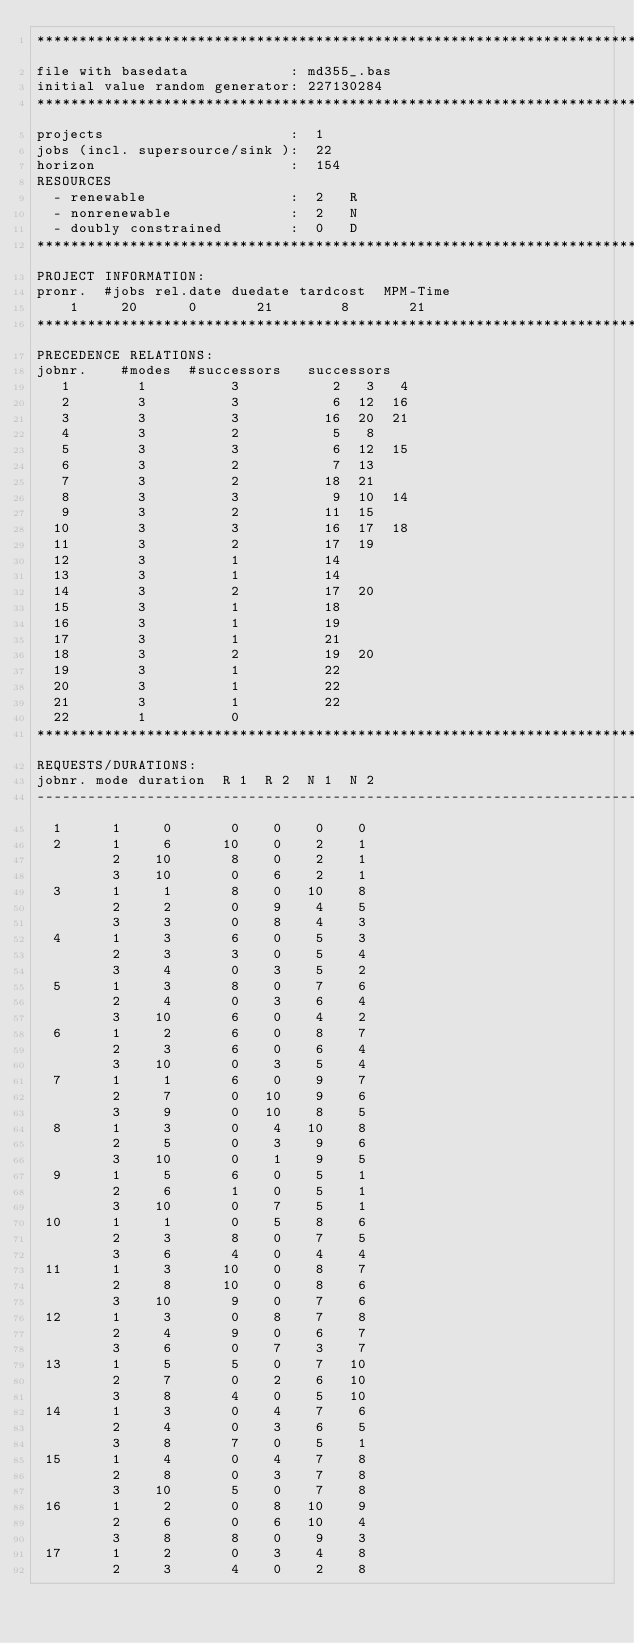Convert code to text. <code><loc_0><loc_0><loc_500><loc_500><_ObjectiveC_>************************************************************************
file with basedata            : md355_.bas
initial value random generator: 227130284
************************************************************************
projects                      :  1
jobs (incl. supersource/sink ):  22
horizon                       :  154
RESOURCES
  - renewable                 :  2   R
  - nonrenewable              :  2   N
  - doubly constrained        :  0   D
************************************************************************
PROJECT INFORMATION:
pronr.  #jobs rel.date duedate tardcost  MPM-Time
    1     20      0       21        8       21
************************************************************************
PRECEDENCE RELATIONS:
jobnr.    #modes  #successors   successors
   1        1          3           2   3   4
   2        3          3           6  12  16
   3        3          3          16  20  21
   4        3          2           5   8
   5        3          3           6  12  15
   6        3          2           7  13
   7        3          2          18  21
   8        3          3           9  10  14
   9        3          2          11  15
  10        3          3          16  17  18
  11        3          2          17  19
  12        3          1          14
  13        3          1          14
  14        3          2          17  20
  15        3          1          18
  16        3          1          19
  17        3          1          21
  18        3          2          19  20
  19        3          1          22
  20        3          1          22
  21        3          1          22
  22        1          0        
************************************************************************
REQUESTS/DURATIONS:
jobnr. mode duration  R 1  R 2  N 1  N 2
------------------------------------------------------------------------
  1      1     0       0    0    0    0
  2      1     6      10    0    2    1
         2    10       8    0    2    1
         3    10       0    6    2    1
  3      1     1       8    0   10    8
         2     2       0    9    4    5
         3     3       0    8    4    3
  4      1     3       6    0    5    3
         2     3       3    0    5    4
         3     4       0    3    5    2
  5      1     3       8    0    7    6
         2     4       0    3    6    4
         3    10       6    0    4    2
  6      1     2       6    0    8    7
         2     3       6    0    6    4
         3    10       0    3    5    4
  7      1     1       6    0    9    7
         2     7       0   10    9    6
         3     9       0   10    8    5
  8      1     3       0    4   10    8
         2     5       0    3    9    6
         3    10       0    1    9    5
  9      1     5       6    0    5    1
         2     6       1    0    5    1
         3    10       0    7    5    1
 10      1     1       0    5    8    6
         2     3       8    0    7    5
         3     6       4    0    4    4
 11      1     3      10    0    8    7
         2     8      10    0    8    6
         3    10       9    0    7    6
 12      1     3       0    8    7    8
         2     4       9    0    6    7
         3     6       0    7    3    7
 13      1     5       5    0    7   10
         2     7       0    2    6   10
         3     8       4    0    5   10
 14      1     3       0    4    7    6
         2     4       0    3    6    5
         3     8       7    0    5    1
 15      1     4       0    4    7    8
         2     8       0    3    7    8
         3    10       5    0    7    8
 16      1     2       0    8   10    9
         2     6       0    6   10    4
         3     8       8    0    9    3
 17      1     2       0    3    4    8
         2     3       4    0    2    8</code> 